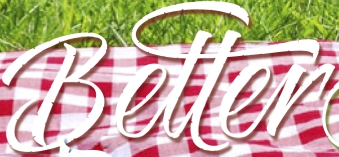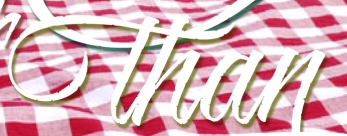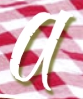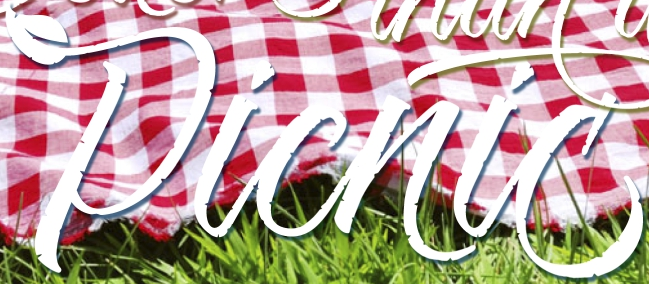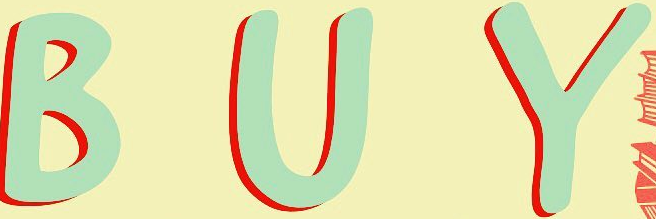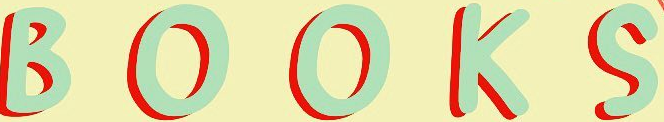What words can you see in these images in sequence, separated by a semicolon? Better; than; a; Picnic; BUY; BOOKS 